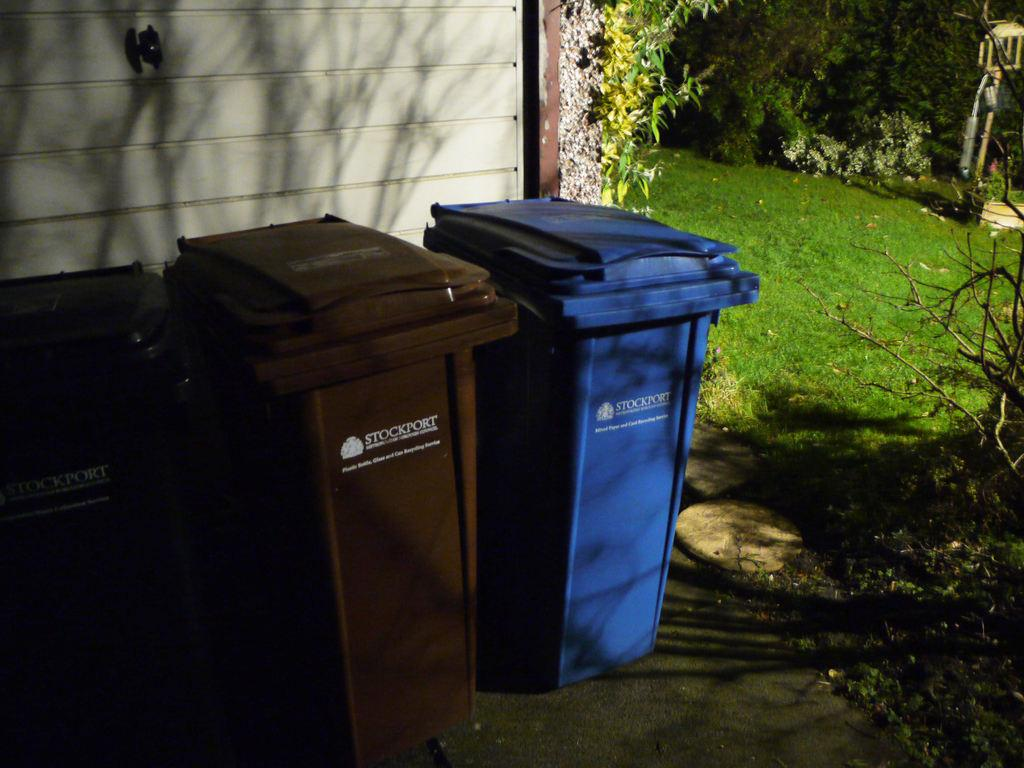<image>
Share a concise interpretation of the image provided. a bin that has the word stockport on it 